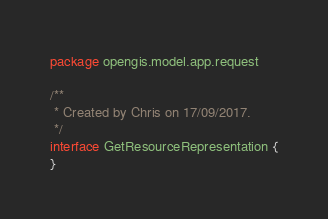<code> <loc_0><loc_0><loc_500><loc_500><_Kotlin_>package opengis.model.app.request

/**
 * Created by Chris on 17/09/2017.
 */
interface GetResourceRepresentation {
}</code> 